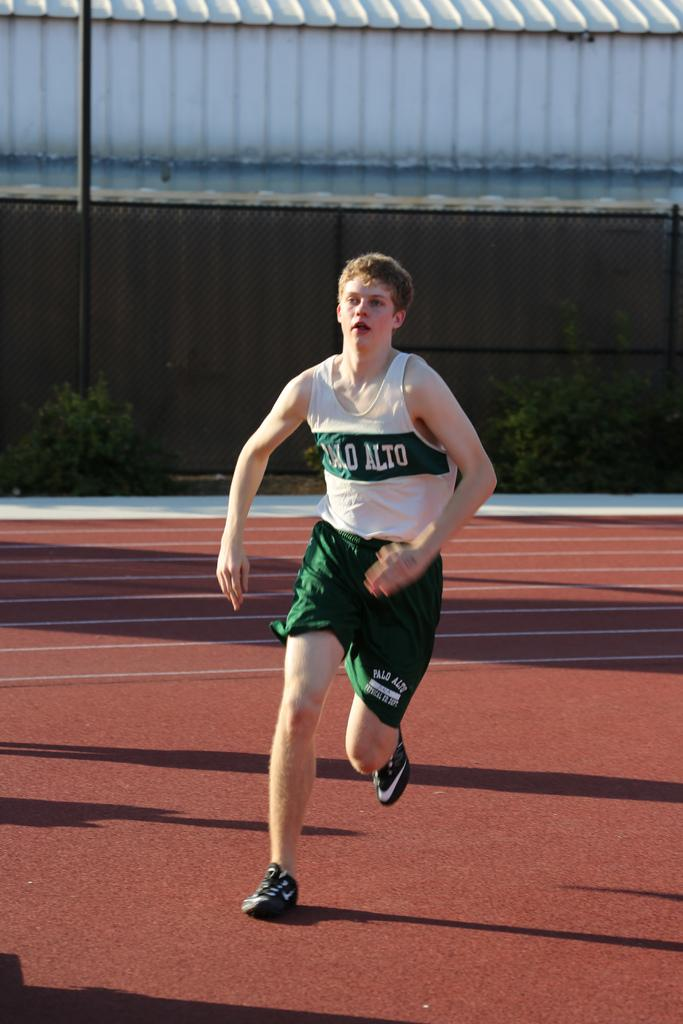<image>
Present a compact description of the photo's key features. the word alto is on the front of the jersey 